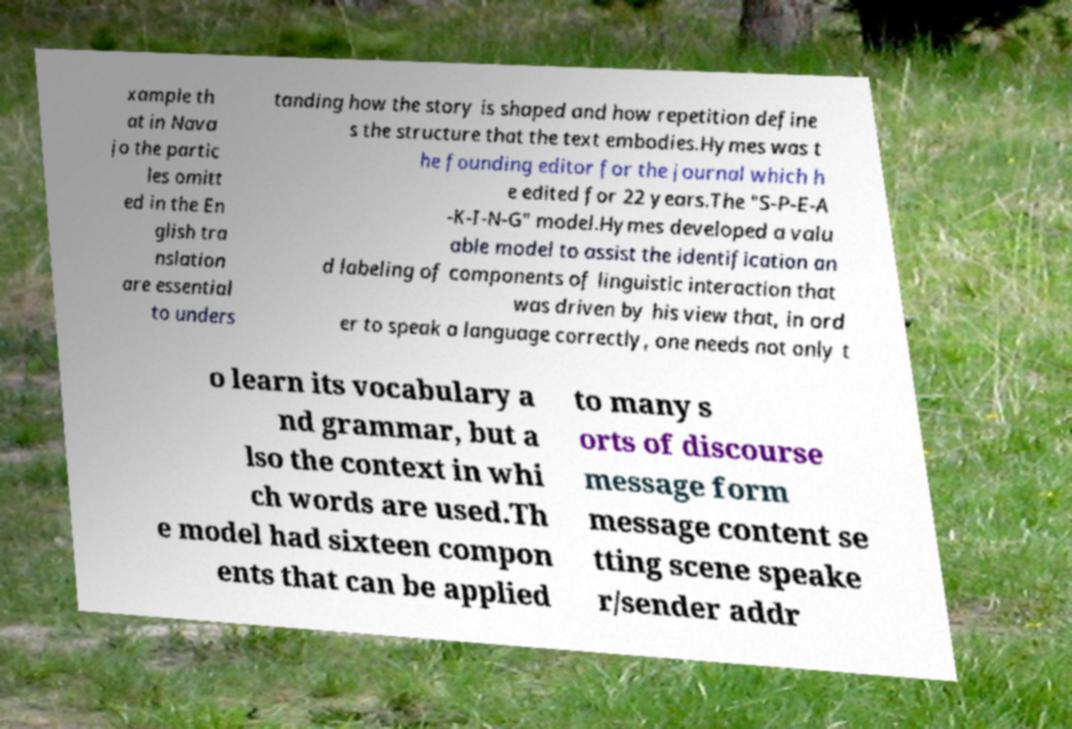Please identify and transcribe the text found in this image. xample th at in Nava jo the partic les omitt ed in the En glish tra nslation are essential to unders tanding how the story is shaped and how repetition define s the structure that the text embodies.Hymes was t he founding editor for the journal which h e edited for 22 years.The "S-P-E-A -K-I-N-G" model.Hymes developed a valu able model to assist the identification an d labeling of components of linguistic interaction that was driven by his view that, in ord er to speak a language correctly, one needs not only t o learn its vocabulary a nd grammar, but a lso the context in whi ch words are used.Th e model had sixteen compon ents that can be applied to many s orts of discourse message form message content se tting scene speake r/sender addr 